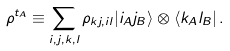<formula> <loc_0><loc_0><loc_500><loc_500>\rho ^ { t _ { A } } \equiv \sum _ { i , j , k , l } \rho _ { k j , i l } | i _ { A } j _ { B } \rangle \otimes \langle k _ { A } l _ { B } | \, .</formula> 